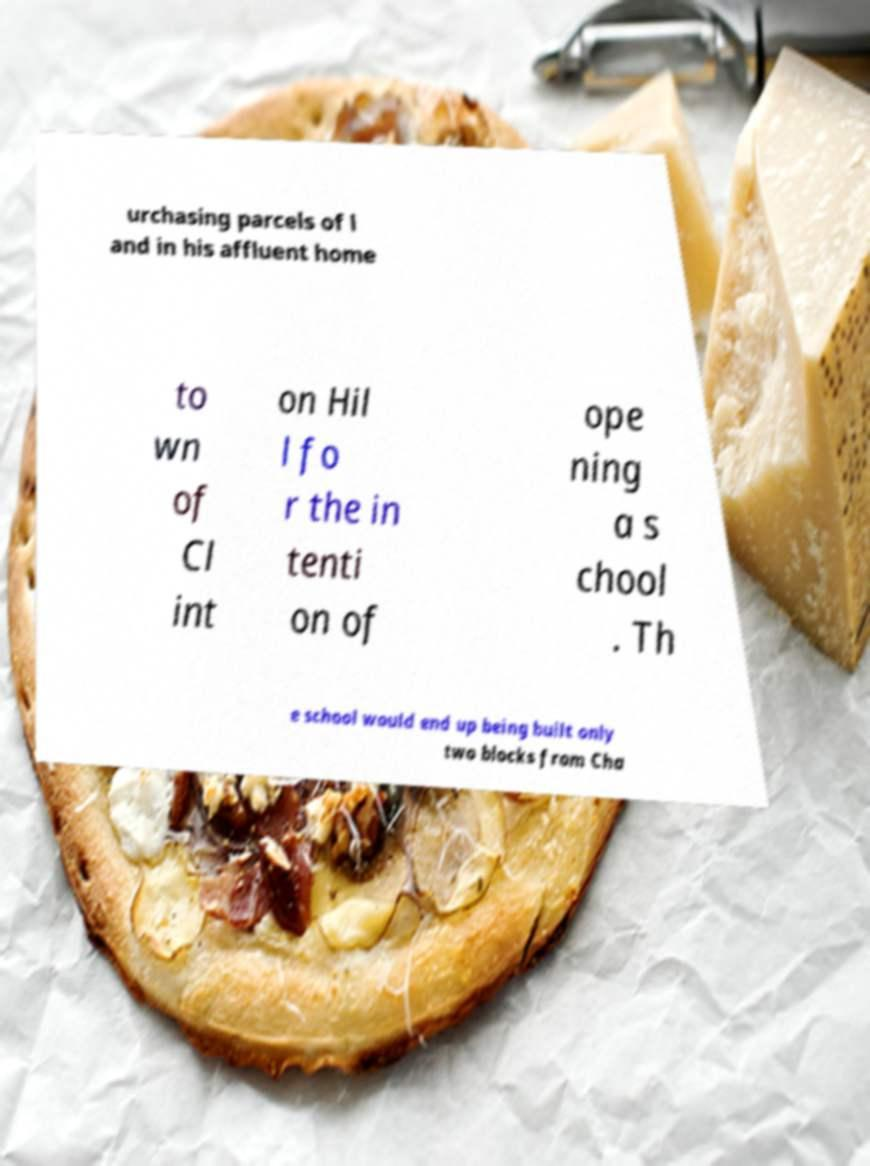For documentation purposes, I need the text within this image transcribed. Could you provide that? urchasing parcels of l and in his affluent home to wn of Cl int on Hil l fo r the in tenti on of ope ning a s chool . Th e school would end up being built only two blocks from Cha 